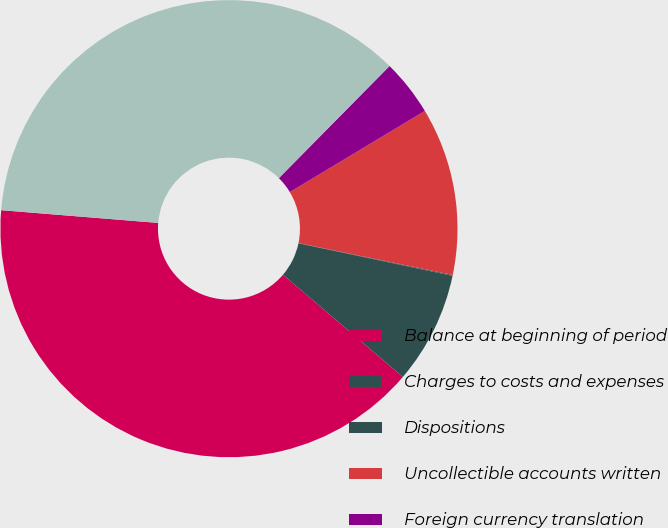Convert chart to OTSL. <chart><loc_0><loc_0><loc_500><loc_500><pie_chart><fcel>Balance at beginning of period<fcel>Charges to costs and expenses<fcel>Dispositions<fcel>Uncollectible accounts written<fcel>Foreign currency translation<fcel>Balance at end of period<nl><fcel>40.05%<fcel>7.93%<fcel>0.06%<fcel>11.86%<fcel>3.99%<fcel>36.11%<nl></chart> 